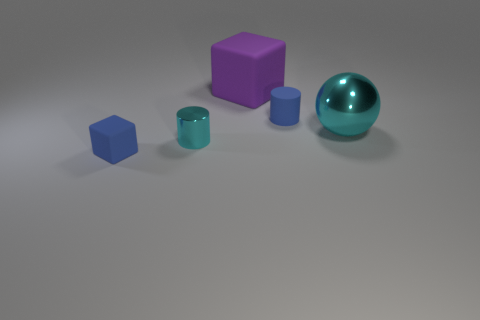Is there another small cube that has the same material as the purple cube?
Your response must be concise. Yes. What number of things are either large yellow metallic spheres or large purple things?
Give a very brief answer. 1. Does the small block have the same material as the large object in front of the big purple matte thing?
Ensure brevity in your answer.  No. There is a blue object that is behind the tiny blue cube; what size is it?
Give a very brief answer. Small. Is the number of matte things less than the number of things?
Your answer should be compact. Yes. Are there any small objects of the same color as the matte cylinder?
Offer a terse response. Yes. What shape is the rubber object that is both behind the tiny shiny object and in front of the purple matte block?
Your answer should be very brief. Cylinder. What shape is the shiny thing that is to the left of the rubber cube that is behind the large cyan ball?
Offer a very short reply. Cylinder. Does the big shiny thing have the same shape as the small cyan shiny object?
Provide a short and direct response. No. What is the material of the big ball that is the same color as the tiny metallic cylinder?
Keep it short and to the point. Metal. 